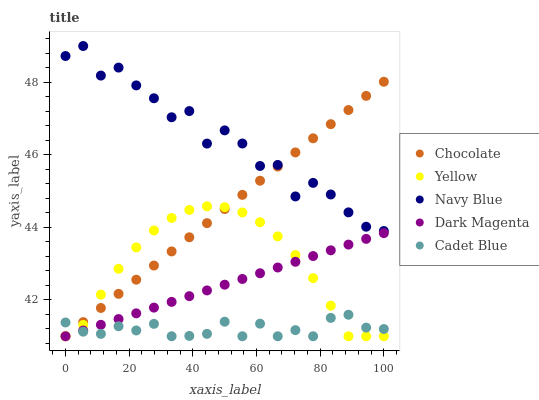Does Cadet Blue have the minimum area under the curve?
Answer yes or no. Yes. Does Navy Blue have the maximum area under the curve?
Answer yes or no. Yes. Does Dark Magenta have the minimum area under the curve?
Answer yes or no. No. Does Dark Magenta have the maximum area under the curve?
Answer yes or no. No. Is Chocolate the smoothest?
Answer yes or no. Yes. Is Navy Blue the roughest?
Answer yes or no. Yes. Is Cadet Blue the smoothest?
Answer yes or no. No. Is Cadet Blue the roughest?
Answer yes or no. No. Does Cadet Blue have the lowest value?
Answer yes or no. Yes. Does Navy Blue have the highest value?
Answer yes or no. Yes. Does Dark Magenta have the highest value?
Answer yes or no. No. Is Cadet Blue less than Navy Blue?
Answer yes or no. Yes. Is Navy Blue greater than Cadet Blue?
Answer yes or no. Yes. Does Chocolate intersect Dark Magenta?
Answer yes or no. Yes. Is Chocolate less than Dark Magenta?
Answer yes or no. No. Is Chocolate greater than Dark Magenta?
Answer yes or no. No. Does Cadet Blue intersect Navy Blue?
Answer yes or no. No. 